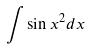Convert formula to latex. <formula><loc_0><loc_0><loc_500><loc_500>\int \sin x ^ { 2 } d x</formula> 